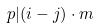<formula> <loc_0><loc_0><loc_500><loc_500>p | ( i - j ) \cdot m</formula> 